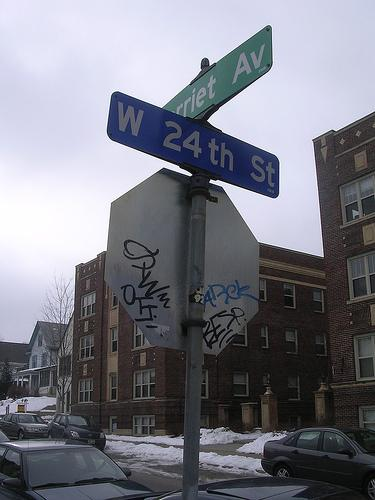Provide a general description of the scene that the image presents. A snowy street lined with parked cars and houses, featuring several street signs and a multi-story building with stone columns. Mention the types/styles of signs and their specific content that are present in the image. Blue and white street name sign (W 24th St), green and white street name sign (Harriet Av), graffiti on back of stop sign, and a real estate sign in a yard. Describe the buildings and structures depicted in the image. A four-story red brick building, multi-story building with windows, building with stone columns, and a sign on a metal pole. List some details about the parked cars in the image. A parked black car, a grey car, a car with sunroof, and a car parked in the snow near the stop sign. What signs are visible in this image, and what is written on them? Blue and white W 24th St sign, green and white Harriet Av sign, graffiti on back of stop sign, and the number 24 on the sign. Summarize the main aspects of the image in a simple sentence. Snowy street with parked cars, street signs, and buildings in a winter setting. Describe the weather and environment in the image. Winter setting with snow on ground, bare tree, parked cars, and white clouds in the gray, cloudy sky above the multi-story building. Explain what's notable about the street signs in the image. A blue and white W 24th St sign, green and white Harriet Av sign, and graffiti on the back of a stop sign. Mention the most prominent objects in the image and their features. Blue and white W 24th St sign, green and white Harriet Av sign, graffiti on back of stop sign, cars parked on snowy street, and a multi-story red brick building. Briefly describe key elements captured in the image. Two street signs, cars parked on snowy street, building with stone columns, graffiti on a stop sign, and a sky with white clouds. 